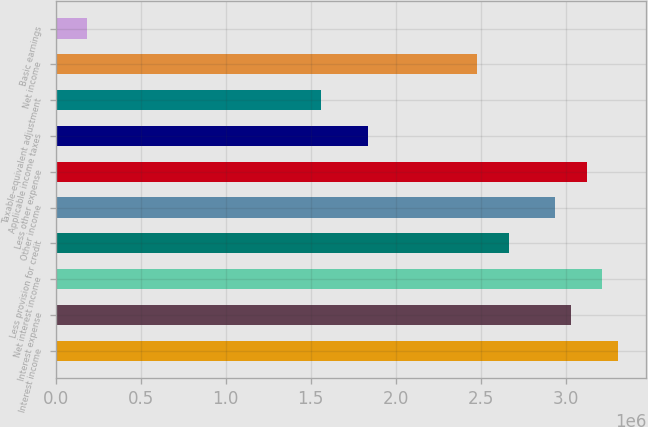Convert chart. <chart><loc_0><loc_0><loc_500><loc_500><bar_chart><fcel>Interest income<fcel>Interest expense<fcel>Net interest income<fcel>Less provision for credit<fcel>Other income<fcel>Less other expense<fcel>Applicable income taxes<fcel>Taxable-equivalent adjustment<fcel>Net income<fcel>Basic earnings<nl><fcel>3.30552e+06<fcel>3.03006e+06<fcel>3.2137e+06<fcel>2.66278e+06<fcel>2.93824e+06<fcel>3.12188e+06<fcel>1.8364e+06<fcel>1.56094e+06<fcel>2.47914e+06<fcel>183640<nl></chart> 